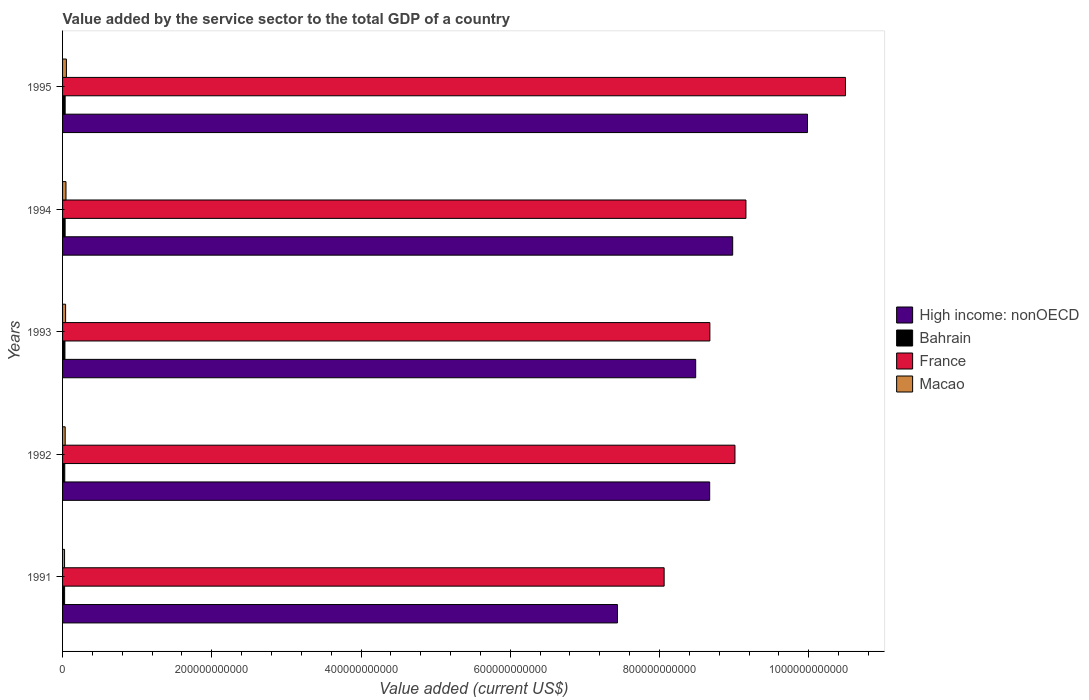Are the number of bars on each tick of the Y-axis equal?
Ensure brevity in your answer.  Yes. What is the label of the 2nd group of bars from the top?
Provide a short and direct response. 1994. What is the value added by the service sector to the total GDP in Macao in 1993?
Your answer should be compact. 4.09e+09. Across all years, what is the maximum value added by the service sector to the total GDP in Macao?
Your answer should be compact. 5.14e+09. Across all years, what is the minimum value added by the service sector to the total GDP in Macao?
Your response must be concise. 2.67e+09. In which year was the value added by the service sector to the total GDP in France maximum?
Offer a very short reply. 1995. What is the total value added by the service sector to the total GDP in High income: nonOECD in the graph?
Offer a terse response. 4.36e+12. What is the difference between the value added by the service sector to the total GDP in Bahrain in 1994 and that in 1995?
Your answer should be compact. -2.63e+07. What is the difference between the value added by the service sector to the total GDP in High income: nonOECD in 1994 and the value added by the service sector to the total GDP in France in 1991?
Offer a very short reply. 9.19e+1. What is the average value added by the service sector to the total GDP in France per year?
Provide a short and direct response. 9.08e+11. In the year 1993, what is the difference between the value added by the service sector to the total GDP in Macao and value added by the service sector to the total GDP in High income: nonOECD?
Offer a terse response. -8.44e+11. In how many years, is the value added by the service sector to the total GDP in High income: nonOECD greater than 840000000000 US$?
Ensure brevity in your answer.  4. What is the ratio of the value added by the service sector to the total GDP in Macao in 1992 to that in 1995?
Keep it short and to the point. 0.68. Is the value added by the service sector to the total GDP in France in 1992 less than that in 1993?
Keep it short and to the point. No. What is the difference between the highest and the second highest value added by the service sector to the total GDP in Macao?
Give a very brief answer. 5.67e+08. What is the difference between the highest and the lowest value added by the service sector to the total GDP in Macao?
Ensure brevity in your answer.  2.47e+09. In how many years, is the value added by the service sector to the total GDP in France greater than the average value added by the service sector to the total GDP in France taken over all years?
Your answer should be very brief. 2. Is the sum of the value added by the service sector to the total GDP in France in 1992 and 1995 greater than the maximum value added by the service sector to the total GDP in High income: nonOECD across all years?
Ensure brevity in your answer.  Yes. What does the 3rd bar from the top in 1992 represents?
Ensure brevity in your answer.  Bahrain. What does the 4th bar from the bottom in 1992 represents?
Give a very brief answer. Macao. How many years are there in the graph?
Provide a succinct answer. 5. What is the difference between two consecutive major ticks on the X-axis?
Ensure brevity in your answer.  2.00e+11. Does the graph contain any zero values?
Your response must be concise. No. Does the graph contain grids?
Give a very brief answer. No. How are the legend labels stacked?
Ensure brevity in your answer.  Vertical. What is the title of the graph?
Offer a very short reply. Value added by the service sector to the total GDP of a country. Does "Curacao" appear as one of the legend labels in the graph?
Make the answer very short. No. What is the label or title of the X-axis?
Your answer should be compact. Value added (current US$). What is the label or title of the Y-axis?
Keep it short and to the point. Years. What is the Value added (current US$) in High income: nonOECD in 1991?
Your answer should be very brief. 7.44e+11. What is the Value added (current US$) of Bahrain in 1991?
Ensure brevity in your answer.  2.74e+09. What is the Value added (current US$) in France in 1991?
Keep it short and to the point. 8.06e+11. What is the Value added (current US$) in Macao in 1991?
Keep it short and to the point. 2.67e+09. What is the Value added (current US$) of High income: nonOECD in 1992?
Make the answer very short. 8.67e+11. What is the Value added (current US$) of Bahrain in 1992?
Your answer should be very brief. 2.94e+09. What is the Value added (current US$) in France in 1992?
Keep it short and to the point. 9.01e+11. What is the Value added (current US$) in Macao in 1992?
Your answer should be compact. 3.52e+09. What is the Value added (current US$) of High income: nonOECD in 1993?
Provide a succinct answer. 8.48e+11. What is the Value added (current US$) of Bahrain in 1993?
Your response must be concise. 3.18e+09. What is the Value added (current US$) of France in 1993?
Provide a short and direct response. 8.67e+11. What is the Value added (current US$) in Macao in 1993?
Offer a very short reply. 4.09e+09. What is the Value added (current US$) in High income: nonOECD in 1994?
Keep it short and to the point. 8.98e+11. What is the Value added (current US$) in Bahrain in 1994?
Offer a terse response. 3.44e+09. What is the Value added (current US$) of France in 1994?
Keep it short and to the point. 9.16e+11. What is the Value added (current US$) in Macao in 1994?
Provide a succinct answer. 4.58e+09. What is the Value added (current US$) of High income: nonOECD in 1995?
Your response must be concise. 9.98e+11. What is the Value added (current US$) in Bahrain in 1995?
Your response must be concise. 3.46e+09. What is the Value added (current US$) in France in 1995?
Provide a short and direct response. 1.05e+12. What is the Value added (current US$) in Macao in 1995?
Your response must be concise. 5.14e+09. Across all years, what is the maximum Value added (current US$) of High income: nonOECD?
Your answer should be very brief. 9.98e+11. Across all years, what is the maximum Value added (current US$) of Bahrain?
Make the answer very short. 3.46e+09. Across all years, what is the maximum Value added (current US$) of France?
Ensure brevity in your answer.  1.05e+12. Across all years, what is the maximum Value added (current US$) in Macao?
Provide a short and direct response. 5.14e+09. Across all years, what is the minimum Value added (current US$) in High income: nonOECD?
Make the answer very short. 7.44e+11. Across all years, what is the minimum Value added (current US$) in Bahrain?
Offer a very short reply. 2.74e+09. Across all years, what is the minimum Value added (current US$) in France?
Ensure brevity in your answer.  8.06e+11. Across all years, what is the minimum Value added (current US$) of Macao?
Your answer should be very brief. 2.67e+09. What is the total Value added (current US$) in High income: nonOECD in the graph?
Keep it short and to the point. 4.36e+12. What is the total Value added (current US$) of Bahrain in the graph?
Offer a very short reply. 1.58e+1. What is the total Value added (current US$) of France in the graph?
Provide a short and direct response. 4.54e+12. What is the total Value added (current US$) of Macao in the graph?
Provide a short and direct response. 2.00e+1. What is the difference between the Value added (current US$) of High income: nonOECD in 1991 and that in 1992?
Your answer should be compact. -1.24e+11. What is the difference between the Value added (current US$) in Bahrain in 1991 and that in 1992?
Your answer should be very brief. -2.05e+08. What is the difference between the Value added (current US$) in France in 1991 and that in 1992?
Give a very brief answer. -9.49e+1. What is the difference between the Value added (current US$) in Macao in 1991 and that in 1992?
Your answer should be very brief. -8.44e+08. What is the difference between the Value added (current US$) in High income: nonOECD in 1991 and that in 1993?
Ensure brevity in your answer.  -1.05e+11. What is the difference between the Value added (current US$) in Bahrain in 1991 and that in 1993?
Provide a short and direct response. -4.47e+08. What is the difference between the Value added (current US$) of France in 1991 and that in 1993?
Your answer should be compact. -6.13e+1. What is the difference between the Value added (current US$) of Macao in 1991 and that in 1993?
Provide a short and direct response. -1.41e+09. What is the difference between the Value added (current US$) in High income: nonOECD in 1991 and that in 1994?
Make the answer very short. -1.54e+11. What is the difference between the Value added (current US$) of Bahrain in 1991 and that in 1994?
Give a very brief answer. -7.01e+08. What is the difference between the Value added (current US$) of France in 1991 and that in 1994?
Your answer should be very brief. -1.10e+11. What is the difference between the Value added (current US$) in Macao in 1991 and that in 1994?
Your response must be concise. -1.90e+09. What is the difference between the Value added (current US$) in High income: nonOECD in 1991 and that in 1995?
Provide a short and direct response. -2.55e+11. What is the difference between the Value added (current US$) of Bahrain in 1991 and that in 1995?
Give a very brief answer. -7.27e+08. What is the difference between the Value added (current US$) of France in 1991 and that in 1995?
Give a very brief answer. -2.43e+11. What is the difference between the Value added (current US$) in Macao in 1991 and that in 1995?
Give a very brief answer. -2.47e+09. What is the difference between the Value added (current US$) of High income: nonOECD in 1992 and that in 1993?
Provide a short and direct response. 1.88e+1. What is the difference between the Value added (current US$) of Bahrain in 1992 and that in 1993?
Your answer should be very brief. -2.43e+08. What is the difference between the Value added (current US$) in France in 1992 and that in 1993?
Provide a short and direct response. 3.36e+1. What is the difference between the Value added (current US$) of Macao in 1992 and that in 1993?
Provide a succinct answer. -5.69e+08. What is the difference between the Value added (current US$) of High income: nonOECD in 1992 and that in 1994?
Give a very brief answer. -3.08e+1. What is the difference between the Value added (current US$) of Bahrain in 1992 and that in 1994?
Give a very brief answer. -4.96e+08. What is the difference between the Value added (current US$) in France in 1992 and that in 1994?
Ensure brevity in your answer.  -1.47e+1. What is the difference between the Value added (current US$) in Macao in 1992 and that in 1994?
Ensure brevity in your answer.  -1.06e+09. What is the difference between the Value added (current US$) in High income: nonOECD in 1992 and that in 1995?
Offer a terse response. -1.31e+11. What is the difference between the Value added (current US$) of Bahrain in 1992 and that in 1995?
Your answer should be compact. -5.22e+08. What is the difference between the Value added (current US$) of France in 1992 and that in 1995?
Ensure brevity in your answer.  -1.48e+11. What is the difference between the Value added (current US$) in Macao in 1992 and that in 1995?
Offer a very short reply. -1.62e+09. What is the difference between the Value added (current US$) of High income: nonOECD in 1993 and that in 1994?
Keep it short and to the point. -4.96e+1. What is the difference between the Value added (current US$) of Bahrain in 1993 and that in 1994?
Provide a short and direct response. -2.53e+08. What is the difference between the Value added (current US$) in France in 1993 and that in 1994?
Provide a succinct answer. -4.83e+1. What is the difference between the Value added (current US$) of Macao in 1993 and that in 1994?
Your answer should be very brief. -4.89e+08. What is the difference between the Value added (current US$) of High income: nonOECD in 1993 and that in 1995?
Provide a succinct answer. -1.50e+11. What is the difference between the Value added (current US$) in Bahrain in 1993 and that in 1995?
Your answer should be compact. -2.80e+08. What is the difference between the Value added (current US$) of France in 1993 and that in 1995?
Offer a terse response. -1.82e+11. What is the difference between the Value added (current US$) of Macao in 1993 and that in 1995?
Ensure brevity in your answer.  -1.06e+09. What is the difference between the Value added (current US$) in High income: nonOECD in 1994 and that in 1995?
Provide a short and direct response. -1.00e+11. What is the difference between the Value added (current US$) of Bahrain in 1994 and that in 1995?
Keep it short and to the point. -2.63e+07. What is the difference between the Value added (current US$) of France in 1994 and that in 1995?
Offer a terse response. -1.33e+11. What is the difference between the Value added (current US$) in Macao in 1994 and that in 1995?
Provide a short and direct response. -5.67e+08. What is the difference between the Value added (current US$) of High income: nonOECD in 1991 and the Value added (current US$) of Bahrain in 1992?
Provide a succinct answer. 7.41e+11. What is the difference between the Value added (current US$) of High income: nonOECD in 1991 and the Value added (current US$) of France in 1992?
Give a very brief answer. -1.57e+11. What is the difference between the Value added (current US$) of High income: nonOECD in 1991 and the Value added (current US$) of Macao in 1992?
Your response must be concise. 7.40e+11. What is the difference between the Value added (current US$) in Bahrain in 1991 and the Value added (current US$) in France in 1992?
Your answer should be very brief. -8.98e+11. What is the difference between the Value added (current US$) in Bahrain in 1991 and the Value added (current US$) in Macao in 1992?
Your answer should be compact. -7.83e+08. What is the difference between the Value added (current US$) of France in 1991 and the Value added (current US$) of Macao in 1992?
Make the answer very short. 8.03e+11. What is the difference between the Value added (current US$) of High income: nonOECD in 1991 and the Value added (current US$) of Bahrain in 1993?
Your answer should be compact. 7.40e+11. What is the difference between the Value added (current US$) in High income: nonOECD in 1991 and the Value added (current US$) in France in 1993?
Give a very brief answer. -1.24e+11. What is the difference between the Value added (current US$) in High income: nonOECD in 1991 and the Value added (current US$) in Macao in 1993?
Your answer should be compact. 7.40e+11. What is the difference between the Value added (current US$) in Bahrain in 1991 and the Value added (current US$) in France in 1993?
Your response must be concise. -8.65e+11. What is the difference between the Value added (current US$) of Bahrain in 1991 and the Value added (current US$) of Macao in 1993?
Offer a terse response. -1.35e+09. What is the difference between the Value added (current US$) in France in 1991 and the Value added (current US$) in Macao in 1993?
Your answer should be compact. 8.02e+11. What is the difference between the Value added (current US$) in High income: nonOECD in 1991 and the Value added (current US$) in Bahrain in 1994?
Offer a very short reply. 7.40e+11. What is the difference between the Value added (current US$) of High income: nonOECD in 1991 and the Value added (current US$) of France in 1994?
Your answer should be very brief. -1.72e+11. What is the difference between the Value added (current US$) of High income: nonOECD in 1991 and the Value added (current US$) of Macao in 1994?
Your response must be concise. 7.39e+11. What is the difference between the Value added (current US$) of Bahrain in 1991 and the Value added (current US$) of France in 1994?
Keep it short and to the point. -9.13e+11. What is the difference between the Value added (current US$) of Bahrain in 1991 and the Value added (current US$) of Macao in 1994?
Make the answer very short. -1.84e+09. What is the difference between the Value added (current US$) in France in 1991 and the Value added (current US$) in Macao in 1994?
Your answer should be compact. 8.02e+11. What is the difference between the Value added (current US$) in High income: nonOECD in 1991 and the Value added (current US$) in Bahrain in 1995?
Make the answer very short. 7.40e+11. What is the difference between the Value added (current US$) in High income: nonOECD in 1991 and the Value added (current US$) in France in 1995?
Offer a terse response. -3.06e+11. What is the difference between the Value added (current US$) of High income: nonOECD in 1991 and the Value added (current US$) of Macao in 1995?
Your answer should be compact. 7.38e+11. What is the difference between the Value added (current US$) in Bahrain in 1991 and the Value added (current US$) in France in 1995?
Your answer should be very brief. -1.05e+12. What is the difference between the Value added (current US$) of Bahrain in 1991 and the Value added (current US$) of Macao in 1995?
Ensure brevity in your answer.  -2.41e+09. What is the difference between the Value added (current US$) of France in 1991 and the Value added (current US$) of Macao in 1995?
Provide a short and direct response. 8.01e+11. What is the difference between the Value added (current US$) in High income: nonOECD in 1992 and the Value added (current US$) in Bahrain in 1993?
Offer a terse response. 8.64e+11. What is the difference between the Value added (current US$) of High income: nonOECD in 1992 and the Value added (current US$) of France in 1993?
Give a very brief answer. -2.55e+08. What is the difference between the Value added (current US$) in High income: nonOECD in 1992 and the Value added (current US$) in Macao in 1993?
Offer a terse response. 8.63e+11. What is the difference between the Value added (current US$) of Bahrain in 1992 and the Value added (current US$) of France in 1993?
Provide a succinct answer. -8.65e+11. What is the difference between the Value added (current US$) of Bahrain in 1992 and the Value added (current US$) of Macao in 1993?
Provide a succinct answer. -1.15e+09. What is the difference between the Value added (current US$) in France in 1992 and the Value added (current US$) in Macao in 1993?
Provide a short and direct response. 8.97e+11. What is the difference between the Value added (current US$) in High income: nonOECD in 1992 and the Value added (current US$) in Bahrain in 1994?
Keep it short and to the point. 8.64e+11. What is the difference between the Value added (current US$) of High income: nonOECD in 1992 and the Value added (current US$) of France in 1994?
Your response must be concise. -4.86e+1. What is the difference between the Value added (current US$) in High income: nonOECD in 1992 and the Value added (current US$) in Macao in 1994?
Give a very brief answer. 8.63e+11. What is the difference between the Value added (current US$) in Bahrain in 1992 and the Value added (current US$) in France in 1994?
Make the answer very short. -9.13e+11. What is the difference between the Value added (current US$) of Bahrain in 1992 and the Value added (current US$) of Macao in 1994?
Offer a very short reply. -1.64e+09. What is the difference between the Value added (current US$) of France in 1992 and the Value added (current US$) of Macao in 1994?
Provide a short and direct response. 8.97e+11. What is the difference between the Value added (current US$) in High income: nonOECD in 1992 and the Value added (current US$) in Bahrain in 1995?
Offer a terse response. 8.64e+11. What is the difference between the Value added (current US$) in High income: nonOECD in 1992 and the Value added (current US$) in France in 1995?
Ensure brevity in your answer.  -1.82e+11. What is the difference between the Value added (current US$) in High income: nonOECD in 1992 and the Value added (current US$) in Macao in 1995?
Make the answer very short. 8.62e+11. What is the difference between the Value added (current US$) in Bahrain in 1992 and the Value added (current US$) in France in 1995?
Offer a very short reply. -1.05e+12. What is the difference between the Value added (current US$) in Bahrain in 1992 and the Value added (current US$) in Macao in 1995?
Your answer should be very brief. -2.20e+09. What is the difference between the Value added (current US$) of France in 1992 and the Value added (current US$) of Macao in 1995?
Ensure brevity in your answer.  8.96e+11. What is the difference between the Value added (current US$) of High income: nonOECD in 1993 and the Value added (current US$) of Bahrain in 1994?
Your response must be concise. 8.45e+11. What is the difference between the Value added (current US$) in High income: nonOECD in 1993 and the Value added (current US$) in France in 1994?
Your answer should be very brief. -6.73e+1. What is the difference between the Value added (current US$) of High income: nonOECD in 1993 and the Value added (current US$) of Macao in 1994?
Provide a succinct answer. 8.44e+11. What is the difference between the Value added (current US$) in Bahrain in 1993 and the Value added (current US$) in France in 1994?
Provide a short and direct response. -9.13e+11. What is the difference between the Value added (current US$) of Bahrain in 1993 and the Value added (current US$) of Macao in 1994?
Ensure brevity in your answer.  -1.39e+09. What is the difference between the Value added (current US$) of France in 1993 and the Value added (current US$) of Macao in 1994?
Offer a terse response. 8.63e+11. What is the difference between the Value added (current US$) in High income: nonOECD in 1993 and the Value added (current US$) in Bahrain in 1995?
Your response must be concise. 8.45e+11. What is the difference between the Value added (current US$) of High income: nonOECD in 1993 and the Value added (current US$) of France in 1995?
Offer a very short reply. -2.01e+11. What is the difference between the Value added (current US$) of High income: nonOECD in 1993 and the Value added (current US$) of Macao in 1995?
Your answer should be very brief. 8.43e+11. What is the difference between the Value added (current US$) in Bahrain in 1993 and the Value added (current US$) in France in 1995?
Provide a succinct answer. -1.05e+12. What is the difference between the Value added (current US$) of Bahrain in 1993 and the Value added (current US$) of Macao in 1995?
Make the answer very short. -1.96e+09. What is the difference between the Value added (current US$) of France in 1993 and the Value added (current US$) of Macao in 1995?
Your response must be concise. 8.62e+11. What is the difference between the Value added (current US$) of High income: nonOECD in 1994 and the Value added (current US$) of Bahrain in 1995?
Ensure brevity in your answer.  8.95e+11. What is the difference between the Value added (current US$) of High income: nonOECD in 1994 and the Value added (current US$) of France in 1995?
Keep it short and to the point. -1.51e+11. What is the difference between the Value added (current US$) of High income: nonOECD in 1994 and the Value added (current US$) of Macao in 1995?
Your answer should be compact. 8.93e+11. What is the difference between the Value added (current US$) of Bahrain in 1994 and the Value added (current US$) of France in 1995?
Your answer should be compact. -1.05e+12. What is the difference between the Value added (current US$) of Bahrain in 1994 and the Value added (current US$) of Macao in 1995?
Your answer should be very brief. -1.71e+09. What is the difference between the Value added (current US$) in France in 1994 and the Value added (current US$) in Macao in 1995?
Ensure brevity in your answer.  9.11e+11. What is the average Value added (current US$) in High income: nonOECD per year?
Offer a very short reply. 8.71e+11. What is the average Value added (current US$) in Bahrain per year?
Ensure brevity in your answer.  3.15e+09. What is the average Value added (current US$) in France per year?
Make the answer very short. 9.08e+11. What is the average Value added (current US$) of Macao per year?
Ensure brevity in your answer.  4.00e+09. In the year 1991, what is the difference between the Value added (current US$) of High income: nonOECD and Value added (current US$) of Bahrain?
Offer a terse response. 7.41e+11. In the year 1991, what is the difference between the Value added (current US$) in High income: nonOECD and Value added (current US$) in France?
Your answer should be compact. -6.26e+1. In the year 1991, what is the difference between the Value added (current US$) of High income: nonOECD and Value added (current US$) of Macao?
Your answer should be very brief. 7.41e+11. In the year 1991, what is the difference between the Value added (current US$) of Bahrain and Value added (current US$) of France?
Your answer should be very brief. -8.03e+11. In the year 1991, what is the difference between the Value added (current US$) of Bahrain and Value added (current US$) of Macao?
Give a very brief answer. 6.14e+07. In the year 1991, what is the difference between the Value added (current US$) in France and Value added (current US$) in Macao?
Your response must be concise. 8.04e+11. In the year 1992, what is the difference between the Value added (current US$) in High income: nonOECD and Value added (current US$) in Bahrain?
Provide a short and direct response. 8.64e+11. In the year 1992, what is the difference between the Value added (current US$) in High income: nonOECD and Value added (current US$) in France?
Your response must be concise. -3.39e+1. In the year 1992, what is the difference between the Value added (current US$) in High income: nonOECD and Value added (current US$) in Macao?
Make the answer very short. 8.64e+11. In the year 1992, what is the difference between the Value added (current US$) of Bahrain and Value added (current US$) of France?
Your response must be concise. -8.98e+11. In the year 1992, what is the difference between the Value added (current US$) in Bahrain and Value added (current US$) in Macao?
Keep it short and to the point. -5.78e+08. In the year 1992, what is the difference between the Value added (current US$) in France and Value added (current US$) in Macao?
Provide a short and direct response. 8.98e+11. In the year 1993, what is the difference between the Value added (current US$) in High income: nonOECD and Value added (current US$) in Bahrain?
Your answer should be very brief. 8.45e+11. In the year 1993, what is the difference between the Value added (current US$) in High income: nonOECD and Value added (current US$) in France?
Your response must be concise. -1.90e+1. In the year 1993, what is the difference between the Value added (current US$) in High income: nonOECD and Value added (current US$) in Macao?
Give a very brief answer. 8.44e+11. In the year 1993, what is the difference between the Value added (current US$) of Bahrain and Value added (current US$) of France?
Make the answer very short. -8.64e+11. In the year 1993, what is the difference between the Value added (current US$) of Bahrain and Value added (current US$) of Macao?
Offer a terse response. -9.04e+08. In the year 1993, what is the difference between the Value added (current US$) of France and Value added (current US$) of Macao?
Your response must be concise. 8.63e+11. In the year 1994, what is the difference between the Value added (current US$) of High income: nonOECD and Value added (current US$) of Bahrain?
Offer a very short reply. 8.95e+11. In the year 1994, what is the difference between the Value added (current US$) in High income: nonOECD and Value added (current US$) in France?
Your answer should be very brief. -1.78e+1. In the year 1994, what is the difference between the Value added (current US$) of High income: nonOECD and Value added (current US$) of Macao?
Your answer should be very brief. 8.93e+11. In the year 1994, what is the difference between the Value added (current US$) in Bahrain and Value added (current US$) in France?
Give a very brief answer. -9.12e+11. In the year 1994, what is the difference between the Value added (current US$) in Bahrain and Value added (current US$) in Macao?
Provide a succinct answer. -1.14e+09. In the year 1994, what is the difference between the Value added (current US$) in France and Value added (current US$) in Macao?
Your answer should be very brief. 9.11e+11. In the year 1995, what is the difference between the Value added (current US$) in High income: nonOECD and Value added (current US$) in Bahrain?
Your response must be concise. 9.95e+11. In the year 1995, what is the difference between the Value added (current US$) of High income: nonOECD and Value added (current US$) of France?
Give a very brief answer. -5.09e+1. In the year 1995, what is the difference between the Value added (current US$) in High income: nonOECD and Value added (current US$) in Macao?
Give a very brief answer. 9.93e+11. In the year 1995, what is the difference between the Value added (current US$) of Bahrain and Value added (current US$) of France?
Provide a short and direct response. -1.05e+12. In the year 1995, what is the difference between the Value added (current US$) in Bahrain and Value added (current US$) in Macao?
Give a very brief answer. -1.68e+09. In the year 1995, what is the difference between the Value added (current US$) in France and Value added (current US$) in Macao?
Offer a terse response. 1.04e+12. What is the ratio of the Value added (current US$) in High income: nonOECD in 1991 to that in 1992?
Your answer should be very brief. 0.86. What is the ratio of the Value added (current US$) in Bahrain in 1991 to that in 1992?
Offer a terse response. 0.93. What is the ratio of the Value added (current US$) in France in 1991 to that in 1992?
Give a very brief answer. 0.89. What is the ratio of the Value added (current US$) of Macao in 1991 to that in 1992?
Provide a succinct answer. 0.76. What is the ratio of the Value added (current US$) of High income: nonOECD in 1991 to that in 1993?
Your answer should be compact. 0.88. What is the ratio of the Value added (current US$) in Bahrain in 1991 to that in 1993?
Offer a terse response. 0.86. What is the ratio of the Value added (current US$) of France in 1991 to that in 1993?
Provide a succinct answer. 0.93. What is the ratio of the Value added (current US$) of Macao in 1991 to that in 1993?
Your answer should be very brief. 0.65. What is the ratio of the Value added (current US$) of High income: nonOECD in 1991 to that in 1994?
Make the answer very short. 0.83. What is the ratio of the Value added (current US$) in Bahrain in 1991 to that in 1994?
Ensure brevity in your answer.  0.8. What is the ratio of the Value added (current US$) in France in 1991 to that in 1994?
Keep it short and to the point. 0.88. What is the ratio of the Value added (current US$) of Macao in 1991 to that in 1994?
Ensure brevity in your answer.  0.58. What is the ratio of the Value added (current US$) in High income: nonOECD in 1991 to that in 1995?
Provide a short and direct response. 0.74. What is the ratio of the Value added (current US$) of Bahrain in 1991 to that in 1995?
Make the answer very short. 0.79. What is the ratio of the Value added (current US$) of France in 1991 to that in 1995?
Offer a very short reply. 0.77. What is the ratio of the Value added (current US$) in Macao in 1991 to that in 1995?
Offer a very short reply. 0.52. What is the ratio of the Value added (current US$) in High income: nonOECD in 1992 to that in 1993?
Provide a short and direct response. 1.02. What is the ratio of the Value added (current US$) of Bahrain in 1992 to that in 1993?
Give a very brief answer. 0.92. What is the ratio of the Value added (current US$) of France in 1992 to that in 1993?
Ensure brevity in your answer.  1.04. What is the ratio of the Value added (current US$) of Macao in 1992 to that in 1993?
Your answer should be very brief. 0.86. What is the ratio of the Value added (current US$) in High income: nonOECD in 1992 to that in 1994?
Ensure brevity in your answer.  0.97. What is the ratio of the Value added (current US$) of Bahrain in 1992 to that in 1994?
Your answer should be very brief. 0.86. What is the ratio of the Value added (current US$) in France in 1992 to that in 1994?
Provide a short and direct response. 0.98. What is the ratio of the Value added (current US$) in Macao in 1992 to that in 1994?
Your answer should be compact. 0.77. What is the ratio of the Value added (current US$) of High income: nonOECD in 1992 to that in 1995?
Your response must be concise. 0.87. What is the ratio of the Value added (current US$) in Bahrain in 1992 to that in 1995?
Your answer should be compact. 0.85. What is the ratio of the Value added (current US$) in France in 1992 to that in 1995?
Provide a short and direct response. 0.86. What is the ratio of the Value added (current US$) in Macao in 1992 to that in 1995?
Provide a short and direct response. 0.68. What is the ratio of the Value added (current US$) in High income: nonOECD in 1993 to that in 1994?
Your answer should be compact. 0.94. What is the ratio of the Value added (current US$) in Bahrain in 1993 to that in 1994?
Keep it short and to the point. 0.93. What is the ratio of the Value added (current US$) of France in 1993 to that in 1994?
Your answer should be very brief. 0.95. What is the ratio of the Value added (current US$) in Macao in 1993 to that in 1994?
Offer a very short reply. 0.89. What is the ratio of the Value added (current US$) of High income: nonOECD in 1993 to that in 1995?
Provide a succinct answer. 0.85. What is the ratio of the Value added (current US$) of Bahrain in 1993 to that in 1995?
Make the answer very short. 0.92. What is the ratio of the Value added (current US$) of France in 1993 to that in 1995?
Make the answer very short. 0.83. What is the ratio of the Value added (current US$) of Macao in 1993 to that in 1995?
Keep it short and to the point. 0.79. What is the ratio of the Value added (current US$) in High income: nonOECD in 1994 to that in 1995?
Offer a terse response. 0.9. What is the ratio of the Value added (current US$) in France in 1994 to that in 1995?
Provide a succinct answer. 0.87. What is the ratio of the Value added (current US$) of Macao in 1994 to that in 1995?
Offer a very short reply. 0.89. What is the difference between the highest and the second highest Value added (current US$) in High income: nonOECD?
Ensure brevity in your answer.  1.00e+11. What is the difference between the highest and the second highest Value added (current US$) of Bahrain?
Your answer should be compact. 2.63e+07. What is the difference between the highest and the second highest Value added (current US$) in France?
Keep it short and to the point. 1.33e+11. What is the difference between the highest and the second highest Value added (current US$) in Macao?
Your response must be concise. 5.67e+08. What is the difference between the highest and the lowest Value added (current US$) of High income: nonOECD?
Offer a terse response. 2.55e+11. What is the difference between the highest and the lowest Value added (current US$) of Bahrain?
Offer a very short reply. 7.27e+08. What is the difference between the highest and the lowest Value added (current US$) of France?
Offer a very short reply. 2.43e+11. What is the difference between the highest and the lowest Value added (current US$) of Macao?
Ensure brevity in your answer.  2.47e+09. 